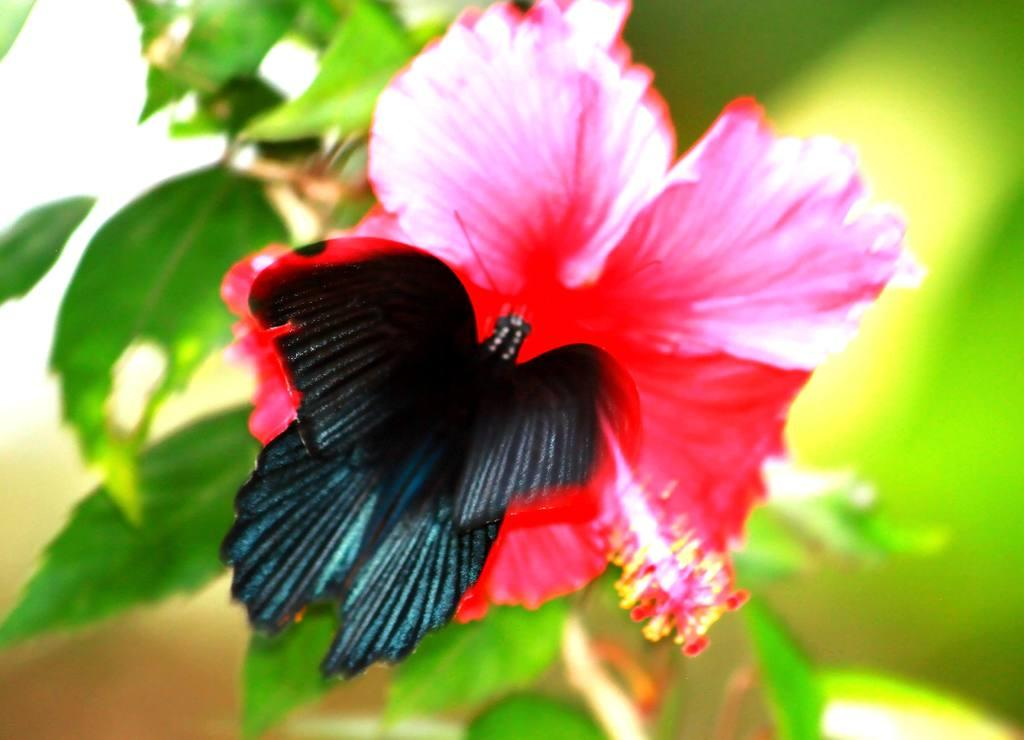What type of insect is in the image? There is a black color butterfly in the image. What is the butterfly resting on? The butterfly is on a pink colored flower. What is the flower part of? The flower is part of a plant. What color are the leaves of the plant? The leaves of the plant are green color. How would you describe the background of the image? The background of the image is blurred. What is the cause of the argument between the railway and the battle in the image? There is no railway or battle present in the image; it features a black color butterfly on a pink colored flower. 